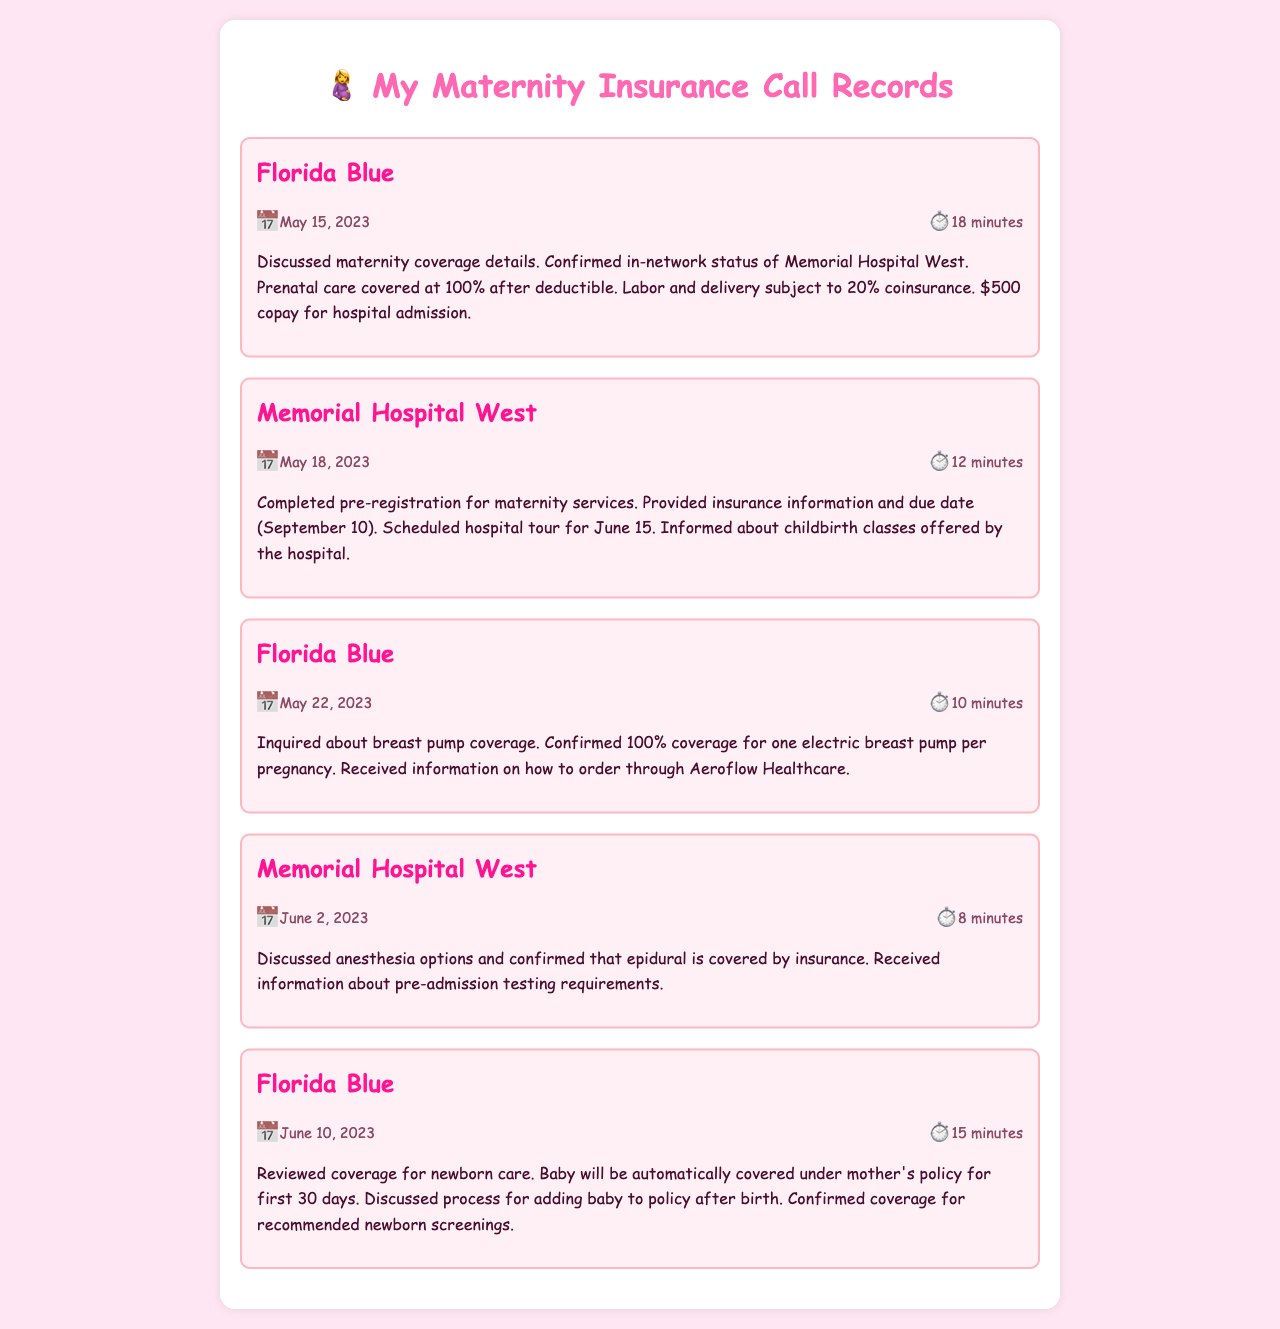what is the date of the call with Florida Blue regarding maternity coverage? The date of the call is provided in the call record for Florida Blue, which is May 15, 2023.
Answer: May 15, 2023 how long was the call about breast pump coverage? The duration of the call about breast pump coverage with Florida Blue is given as 10 minutes.
Answer: 10 minutes what is the due date mentioned during the pre-registration call? The due date is mentioned during the call with Memorial Hospital West as September 10.
Answer: September 10 what is the copay for hospital admission according to Florida Blue? The copay for hospital admission is specified in the call with Florida Blue as $500.
Answer: $500 who provides the childbirth classes mentioned in the call? The call indicates that the childbirth classes are offered by Memorial Hospital West.
Answer: Memorial Hospital West what anesthesia option was confirmed to be covered by insurance? The call with Memorial Hospital West confirms that epidural anesthesia is covered by insurance.
Answer: epidural how many days is the newborn covered automatically under the mother's policy? The document states that the newborn will be covered under the mother's policy for the first 30 days.
Answer: 30 days when is the scheduled hospital tour? The call record indicates that the scheduled hospital tour is on June 15.
Answer: June 15 